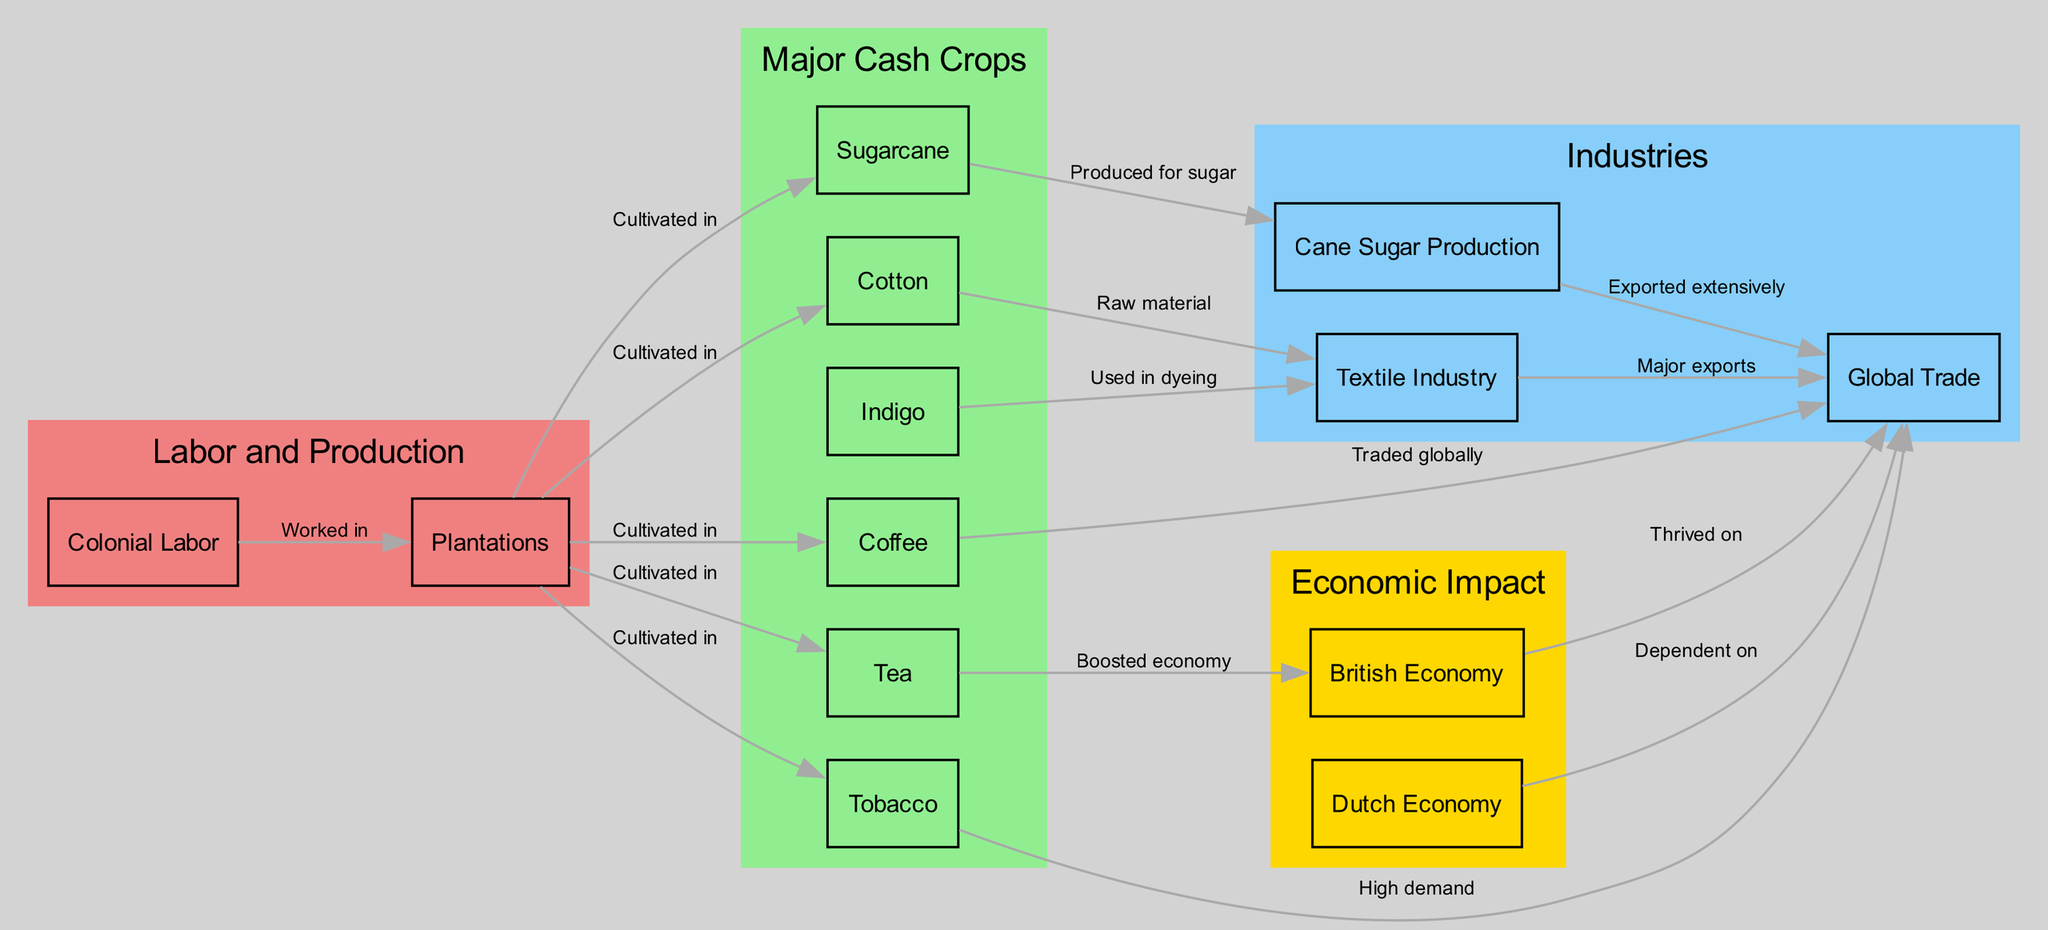What is produced from sugarcane? The diagram shows that sugarcane is related to cane sugar production, and it's clearly labeled that sugarcane is "Produced for sugar."
Answer: sugar Which industry does cotton serve as a raw material? The edge from cotton leads to the textile industry, labeled as "Raw material," indicating that cotton is utilized in that industry.
Answer: textile industry How many major cash crops are illustrated in the diagram? The diagram includes six crops: sugarcane, cotton, coffee, tea, tobacco, and indigo. Counting these nodes gives a total of six.
Answer: 6 What commodity boosted the British economy? The diagram links tea to the British economy with the label "Boosted economy," indicating that tea was significant for economic growth in Britain.
Answer: tea Which labor group worked on plantations? There is a direct connection from colonial labor to plantations, indicated by the label "Worked in," which tells us that colonial labor was involved in plantation work.
Answer: colonial labor What is the relationship between cane sugar production and global trade? The diagram shows an edge from cane sugar production to global trade with the label "Exported extensively," indicating that production directly contributes to global trade.
Answer: Exported extensively Which economy is dependent on global trade? The connection from the Dutch economy to global trade, labeled "Dependent on," clarifies that the Dutch economy relies on trade with the global market.
Answer: Dutch Economy Which crop is used in dyeing? The diagram has an edge indicating that indigo is linked to the textile industry with the label "Used in dyeing," showing indigo's role in dye manufacturing.
Answer: indigo What type of labor was employed in the cultivation of cash crops? The connection from colonial labor to plantations indicates that the labor used for cultivating crops on plantations was colonial in nature.
Answer: colonial labor 